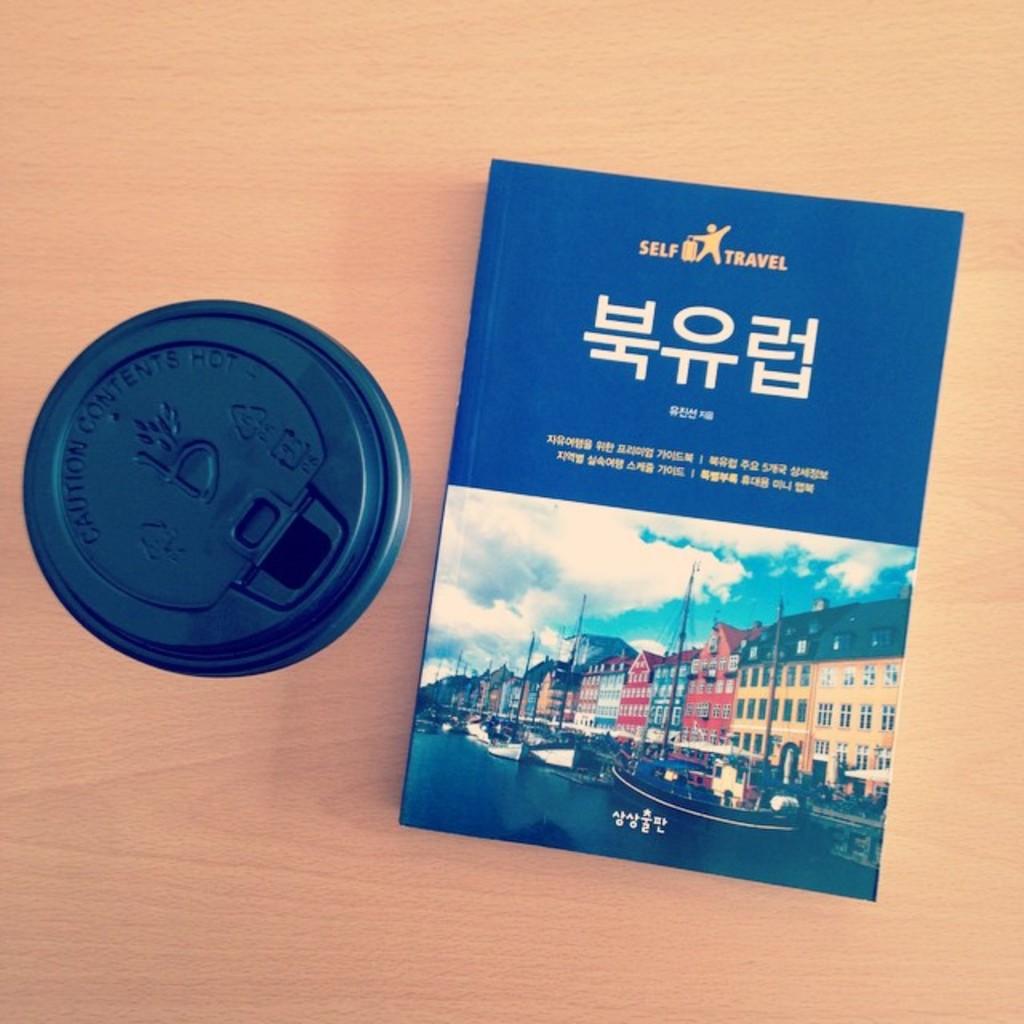What item is on the right?
Your answer should be compact. Book. 